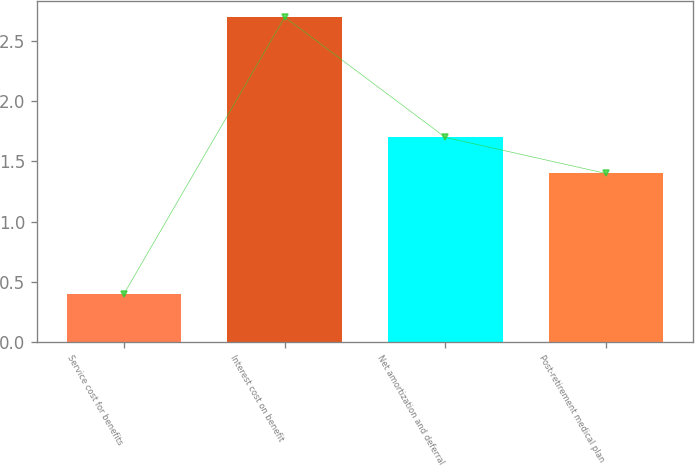Convert chart to OTSL. <chart><loc_0><loc_0><loc_500><loc_500><bar_chart><fcel>Service cost for benefits<fcel>Interest cost on benefit<fcel>Net amortization and deferral<fcel>Post-retirement medical plan<nl><fcel>0.4<fcel>2.7<fcel>1.7<fcel>1.4<nl></chart> 